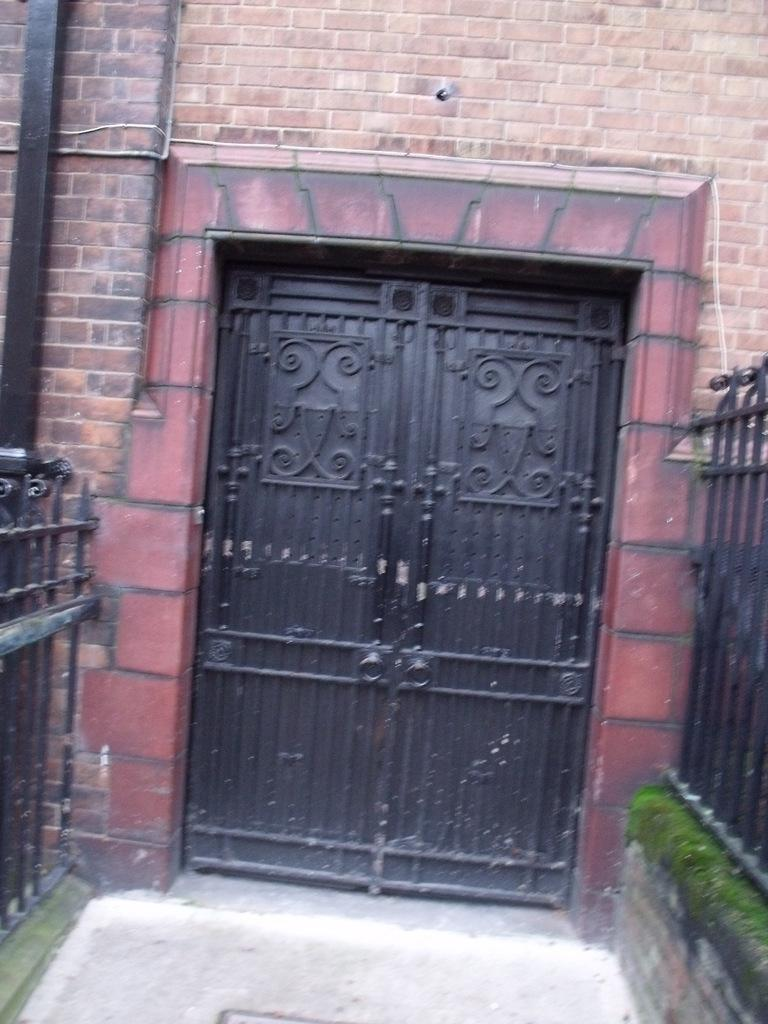What is located in the middle of the image? There is a door in the middle of the image. What is the color of the door? The door is black in color. What can be seen on the left side of the image? There is an iron railing on the left side of the image. What is present on the right side of the image? There is an iron railing on the right side of the image. What type of zephyr can be seen blowing through the door in the image? There is no zephyr present in the image, as a zephyr refers to a gentle breeze, and the image only shows a door and iron railings. 